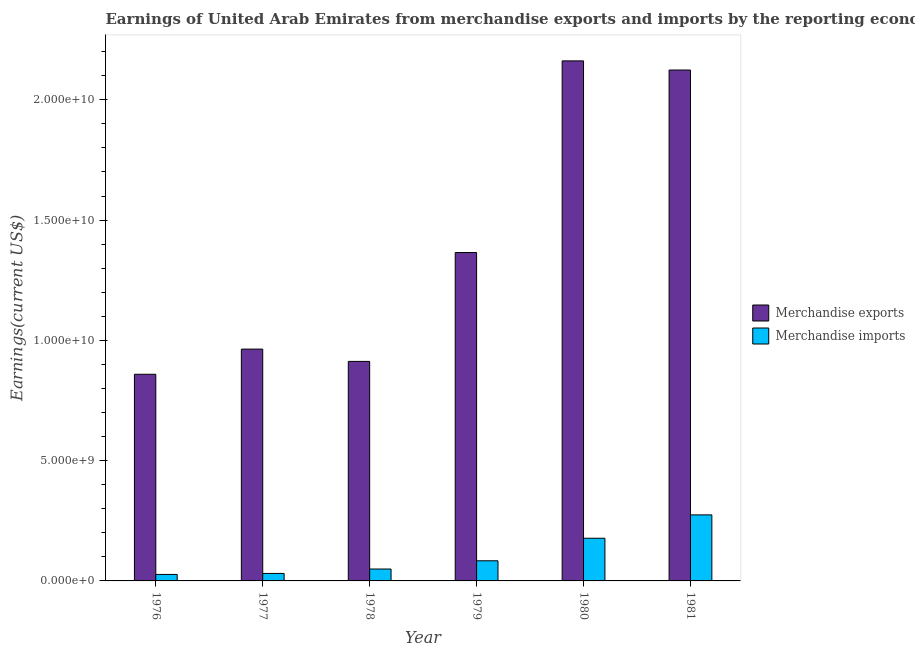How many different coloured bars are there?
Provide a short and direct response. 2. How many groups of bars are there?
Offer a terse response. 6. Are the number of bars on each tick of the X-axis equal?
Your response must be concise. Yes. How many bars are there on the 3rd tick from the left?
Offer a terse response. 2. How many bars are there on the 5th tick from the right?
Keep it short and to the point. 2. In how many cases, is the number of bars for a given year not equal to the number of legend labels?
Offer a very short reply. 0. What is the earnings from merchandise imports in 1981?
Give a very brief answer. 2.75e+09. Across all years, what is the maximum earnings from merchandise exports?
Your answer should be compact. 2.16e+1. Across all years, what is the minimum earnings from merchandise imports?
Ensure brevity in your answer.  2.70e+08. In which year was the earnings from merchandise imports minimum?
Keep it short and to the point. 1976. What is the total earnings from merchandise imports in the graph?
Keep it short and to the point. 6.43e+09. What is the difference between the earnings from merchandise imports in 1977 and that in 1981?
Ensure brevity in your answer.  -2.43e+09. What is the difference between the earnings from merchandise imports in 1977 and the earnings from merchandise exports in 1976?
Make the answer very short. 4.09e+07. What is the average earnings from merchandise imports per year?
Offer a terse response. 1.07e+09. In the year 1980, what is the difference between the earnings from merchandise imports and earnings from merchandise exports?
Offer a terse response. 0. What is the ratio of the earnings from merchandise exports in 1977 to that in 1980?
Your answer should be compact. 0.45. Is the difference between the earnings from merchandise imports in 1980 and 1981 greater than the difference between the earnings from merchandise exports in 1980 and 1981?
Your answer should be very brief. No. What is the difference between the highest and the second highest earnings from merchandise exports?
Offer a very short reply. 3.80e+08. What is the difference between the highest and the lowest earnings from merchandise imports?
Keep it short and to the point. 2.48e+09. Is the sum of the earnings from merchandise exports in 1978 and 1979 greater than the maximum earnings from merchandise imports across all years?
Your answer should be compact. Yes. What does the 2nd bar from the left in 1980 represents?
Provide a short and direct response. Merchandise imports. What does the 2nd bar from the right in 1977 represents?
Give a very brief answer. Merchandise exports. How many bars are there?
Keep it short and to the point. 12. Are all the bars in the graph horizontal?
Provide a succinct answer. No. Are the values on the major ticks of Y-axis written in scientific E-notation?
Provide a short and direct response. Yes. Does the graph contain any zero values?
Offer a terse response. No. Does the graph contain grids?
Make the answer very short. No. Where does the legend appear in the graph?
Keep it short and to the point. Center right. What is the title of the graph?
Your answer should be very brief. Earnings of United Arab Emirates from merchandise exports and imports by the reporting economy. What is the label or title of the Y-axis?
Your response must be concise. Earnings(current US$). What is the Earnings(current US$) of Merchandise exports in 1976?
Your answer should be very brief. 8.59e+09. What is the Earnings(current US$) of Merchandise imports in 1976?
Offer a terse response. 2.70e+08. What is the Earnings(current US$) in Merchandise exports in 1977?
Provide a succinct answer. 9.64e+09. What is the Earnings(current US$) in Merchandise imports in 1977?
Offer a terse response. 3.11e+08. What is the Earnings(current US$) of Merchandise exports in 1978?
Offer a very short reply. 9.13e+09. What is the Earnings(current US$) of Merchandise imports in 1978?
Offer a terse response. 4.95e+08. What is the Earnings(current US$) of Merchandise exports in 1979?
Provide a succinct answer. 1.37e+1. What is the Earnings(current US$) of Merchandise imports in 1979?
Your answer should be compact. 8.37e+08. What is the Earnings(current US$) of Merchandise exports in 1980?
Your response must be concise. 2.16e+1. What is the Earnings(current US$) of Merchandise imports in 1980?
Offer a terse response. 1.77e+09. What is the Earnings(current US$) of Merchandise exports in 1981?
Keep it short and to the point. 2.12e+1. What is the Earnings(current US$) in Merchandise imports in 1981?
Your response must be concise. 2.75e+09. Across all years, what is the maximum Earnings(current US$) of Merchandise exports?
Give a very brief answer. 2.16e+1. Across all years, what is the maximum Earnings(current US$) in Merchandise imports?
Offer a terse response. 2.75e+09. Across all years, what is the minimum Earnings(current US$) in Merchandise exports?
Give a very brief answer. 8.59e+09. Across all years, what is the minimum Earnings(current US$) of Merchandise imports?
Offer a terse response. 2.70e+08. What is the total Earnings(current US$) of Merchandise exports in the graph?
Your answer should be very brief. 8.39e+1. What is the total Earnings(current US$) of Merchandise imports in the graph?
Your answer should be compact. 6.43e+09. What is the difference between the Earnings(current US$) in Merchandise exports in 1976 and that in 1977?
Your answer should be compact. -1.05e+09. What is the difference between the Earnings(current US$) in Merchandise imports in 1976 and that in 1977?
Your response must be concise. -4.09e+07. What is the difference between the Earnings(current US$) of Merchandise exports in 1976 and that in 1978?
Offer a very short reply. -5.35e+08. What is the difference between the Earnings(current US$) of Merchandise imports in 1976 and that in 1978?
Your answer should be very brief. -2.25e+08. What is the difference between the Earnings(current US$) in Merchandise exports in 1976 and that in 1979?
Ensure brevity in your answer.  -5.06e+09. What is the difference between the Earnings(current US$) of Merchandise imports in 1976 and that in 1979?
Provide a short and direct response. -5.67e+08. What is the difference between the Earnings(current US$) of Merchandise exports in 1976 and that in 1980?
Make the answer very short. -1.30e+1. What is the difference between the Earnings(current US$) of Merchandise imports in 1976 and that in 1980?
Your response must be concise. -1.50e+09. What is the difference between the Earnings(current US$) in Merchandise exports in 1976 and that in 1981?
Provide a succinct answer. -1.26e+1. What is the difference between the Earnings(current US$) of Merchandise imports in 1976 and that in 1981?
Ensure brevity in your answer.  -2.48e+09. What is the difference between the Earnings(current US$) in Merchandise exports in 1977 and that in 1978?
Provide a succinct answer. 5.12e+08. What is the difference between the Earnings(current US$) of Merchandise imports in 1977 and that in 1978?
Give a very brief answer. -1.84e+08. What is the difference between the Earnings(current US$) in Merchandise exports in 1977 and that in 1979?
Your answer should be very brief. -4.01e+09. What is the difference between the Earnings(current US$) of Merchandise imports in 1977 and that in 1979?
Your answer should be compact. -5.26e+08. What is the difference between the Earnings(current US$) of Merchandise exports in 1977 and that in 1980?
Offer a very short reply. -1.20e+1. What is the difference between the Earnings(current US$) in Merchandise imports in 1977 and that in 1980?
Your answer should be very brief. -1.46e+09. What is the difference between the Earnings(current US$) of Merchandise exports in 1977 and that in 1981?
Make the answer very short. -1.16e+1. What is the difference between the Earnings(current US$) of Merchandise imports in 1977 and that in 1981?
Offer a terse response. -2.43e+09. What is the difference between the Earnings(current US$) of Merchandise exports in 1978 and that in 1979?
Your answer should be very brief. -4.53e+09. What is the difference between the Earnings(current US$) of Merchandise imports in 1978 and that in 1979?
Provide a succinct answer. -3.42e+08. What is the difference between the Earnings(current US$) of Merchandise exports in 1978 and that in 1980?
Provide a short and direct response. -1.25e+1. What is the difference between the Earnings(current US$) in Merchandise imports in 1978 and that in 1980?
Offer a terse response. -1.28e+09. What is the difference between the Earnings(current US$) of Merchandise exports in 1978 and that in 1981?
Give a very brief answer. -1.21e+1. What is the difference between the Earnings(current US$) in Merchandise imports in 1978 and that in 1981?
Keep it short and to the point. -2.25e+09. What is the difference between the Earnings(current US$) of Merchandise exports in 1979 and that in 1980?
Your answer should be compact. -7.97e+09. What is the difference between the Earnings(current US$) in Merchandise imports in 1979 and that in 1980?
Make the answer very short. -9.37e+08. What is the difference between the Earnings(current US$) of Merchandise exports in 1979 and that in 1981?
Offer a terse response. -7.59e+09. What is the difference between the Earnings(current US$) in Merchandise imports in 1979 and that in 1981?
Ensure brevity in your answer.  -1.91e+09. What is the difference between the Earnings(current US$) of Merchandise exports in 1980 and that in 1981?
Your answer should be compact. 3.80e+08. What is the difference between the Earnings(current US$) of Merchandise imports in 1980 and that in 1981?
Your answer should be compact. -9.72e+08. What is the difference between the Earnings(current US$) of Merchandise exports in 1976 and the Earnings(current US$) of Merchandise imports in 1977?
Give a very brief answer. 8.28e+09. What is the difference between the Earnings(current US$) of Merchandise exports in 1976 and the Earnings(current US$) of Merchandise imports in 1978?
Keep it short and to the point. 8.10e+09. What is the difference between the Earnings(current US$) in Merchandise exports in 1976 and the Earnings(current US$) in Merchandise imports in 1979?
Your response must be concise. 7.75e+09. What is the difference between the Earnings(current US$) in Merchandise exports in 1976 and the Earnings(current US$) in Merchandise imports in 1980?
Give a very brief answer. 6.82e+09. What is the difference between the Earnings(current US$) in Merchandise exports in 1976 and the Earnings(current US$) in Merchandise imports in 1981?
Provide a short and direct response. 5.85e+09. What is the difference between the Earnings(current US$) of Merchandise exports in 1977 and the Earnings(current US$) of Merchandise imports in 1978?
Your answer should be compact. 9.14e+09. What is the difference between the Earnings(current US$) in Merchandise exports in 1977 and the Earnings(current US$) in Merchandise imports in 1979?
Make the answer very short. 8.80e+09. What is the difference between the Earnings(current US$) in Merchandise exports in 1977 and the Earnings(current US$) in Merchandise imports in 1980?
Your answer should be very brief. 7.86e+09. What is the difference between the Earnings(current US$) in Merchandise exports in 1977 and the Earnings(current US$) in Merchandise imports in 1981?
Provide a short and direct response. 6.89e+09. What is the difference between the Earnings(current US$) of Merchandise exports in 1978 and the Earnings(current US$) of Merchandise imports in 1979?
Make the answer very short. 8.29e+09. What is the difference between the Earnings(current US$) in Merchandise exports in 1978 and the Earnings(current US$) in Merchandise imports in 1980?
Your answer should be compact. 7.35e+09. What is the difference between the Earnings(current US$) of Merchandise exports in 1978 and the Earnings(current US$) of Merchandise imports in 1981?
Ensure brevity in your answer.  6.38e+09. What is the difference between the Earnings(current US$) in Merchandise exports in 1979 and the Earnings(current US$) in Merchandise imports in 1980?
Provide a short and direct response. 1.19e+1. What is the difference between the Earnings(current US$) of Merchandise exports in 1979 and the Earnings(current US$) of Merchandise imports in 1981?
Provide a succinct answer. 1.09e+1. What is the difference between the Earnings(current US$) in Merchandise exports in 1980 and the Earnings(current US$) in Merchandise imports in 1981?
Provide a short and direct response. 1.89e+1. What is the average Earnings(current US$) in Merchandise exports per year?
Offer a terse response. 1.40e+1. What is the average Earnings(current US$) in Merchandise imports per year?
Your response must be concise. 1.07e+09. In the year 1976, what is the difference between the Earnings(current US$) of Merchandise exports and Earnings(current US$) of Merchandise imports?
Offer a very short reply. 8.32e+09. In the year 1977, what is the difference between the Earnings(current US$) in Merchandise exports and Earnings(current US$) in Merchandise imports?
Keep it short and to the point. 9.33e+09. In the year 1978, what is the difference between the Earnings(current US$) of Merchandise exports and Earnings(current US$) of Merchandise imports?
Provide a short and direct response. 8.63e+09. In the year 1979, what is the difference between the Earnings(current US$) in Merchandise exports and Earnings(current US$) in Merchandise imports?
Ensure brevity in your answer.  1.28e+1. In the year 1980, what is the difference between the Earnings(current US$) in Merchandise exports and Earnings(current US$) in Merchandise imports?
Keep it short and to the point. 1.98e+1. In the year 1981, what is the difference between the Earnings(current US$) in Merchandise exports and Earnings(current US$) in Merchandise imports?
Provide a succinct answer. 1.85e+1. What is the ratio of the Earnings(current US$) of Merchandise exports in 1976 to that in 1977?
Provide a short and direct response. 0.89. What is the ratio of the Earnings(current US$) in Merchandise imports in 1976 to that in 1977?
Your answer should be compact. 0.87. What is the ratio of the Earnings(current US$) of Merchandise exports in 1976 to that in 1978?
Provide a succinct answer. 0.94. What is the ratio of the Earnings(current US$) in Merchandise imports in 1976 to that in 1978?
Offer a terse response. 0.55. What is the ratio of the Earnings(current US$) of Merchandise exports in 1976 to that in 1979?
Your answer should be very brief. 0.63. What is the ratio of the Earnings(current US$) in Merchandise imports in 1976 to that in 1979?
Offer a very short reply. 0.32. What is the ratio of the Earnings(current US$) in Merchandise exports in 1976 to that in 1980?
Offer a very short reply. 0.4. What is the ratio of the Earnings(current US$) of Merchandise imports in 1976 to that in 1980?
Your response must be concise. 0.15. What is the ratio of the Earnings(current US$) of Merchandise exports in 1976 to that in 1981?
Your response must be concise. 0.4. What is the ratio of the Earnings(current US$) in Merchandise imports in 1976 to that in 1981?
Make the answer very short. 0.1. What is the ratio of the Earnings(current US$) of Merchandise exports in 1977 to that in 1978?
Ensure brevity in your answer.  1.06. What is the ratio of the Earnings(current US$) in Merchandise imports in 1977 to that in 1978?
Provide a short and direct response. 0.63. What is the ratio of the Earnings(current US$) of Merchandise exports in 1977 to that in 1979?
Provide a succinct answer. 0.71. What is the ratio of the Earnings(current US$) in Merchandise imports in 1977 to that in 1979?
Keep it short and to the point. 0.37. What is the ratio of the Earnings(current US$) in Merchandise exports in 1977 to that in 1980?
Offer a terse response. 0.45. What is the ratio of the Earnings(current US$) of Merchandise imports in 1977 to that in 1980?
Give a very brief answer. 0.18. What is the ratio of the Earnings(current US$) in Merchandise exports in 1977 to that in 1981?
Keep it short and to the point. 0.45. What is the ratio of the Earnings(current US$) of Merchandise imports in 1977 to that in 1981?
Your response must be concise. 0.11. What is the ratio of the Earnings(current US$) in Merchandise exports in 1978 to that in 1979?
Give a very brief answer. 0.67. What is the ratio of the Earnings(current US$) in Merchandise imports in 1978 to that in 1979?
Ensure brevity in your answer.  0.59. What is the ratio of the Earnings(current US$) of Merchandise exports in 1978 to that in 1980?
Ensure brevity in your answer.  0.42. What is the ratio of the Earnings(current US$) in Merchandise imports in 1978 to that in 1980?
Provide a short and direct response. 0.28. What is the ratio of the Earnings(current US$) of Merchandise exports in 1978 to that in 1981?
Ensure brevity in your answer.  0.43. What is the ratio of the Earnings(current US$) of Merchandise imports in 1978 to that in 1981?
Offer a very short reply. 0.18. What is the ratio of the Earnings(current US$) of Merchandise exports in 1979 to that in 1980?
Your response must be concise. 0.63. What is the ratio of the Earnings(current US$) of Merchandise imports in 1979 to that in 1980?
Your answer should be compact. 0.47. What is the ratio of the Earnings(current US$) in Merchandise exports in 1979 to that in 1981?
Your answer should be very brief. 0.64. What is the ratio of the Earnings(current US$) in Merchandise imports in 1979 to that in 1981?
Provide a succinct answer. 0.3. What is the ratio of the Earnings(current US$) of Merchandise exports in 1980 to that in 1981?
Your response must be concise. 1.02. What is the ratio of the Earnings(current US$) of Merchandise imports in 1980 to that in 1981?
Make the answer very short. 0.65. What is the difference between the highest and the second highest Earnings(current US$) in Merchandise exports?
Ensure brevity in your answer.  3.80e+08. What is the difference between the highest and the second highest Earnings(current US$) in Merchandise imports?
Offer a terse response. 9.72e+08. What is the difference between the highest and the lowest Earnings(current US$) of Merchandise exports?
Provide a succinct answer. 1.30e+1. What is the difference between the highest and the lowest Earnings(current US$) in Merchandise imports?
Your answer should be compact. 2.48e+09. 